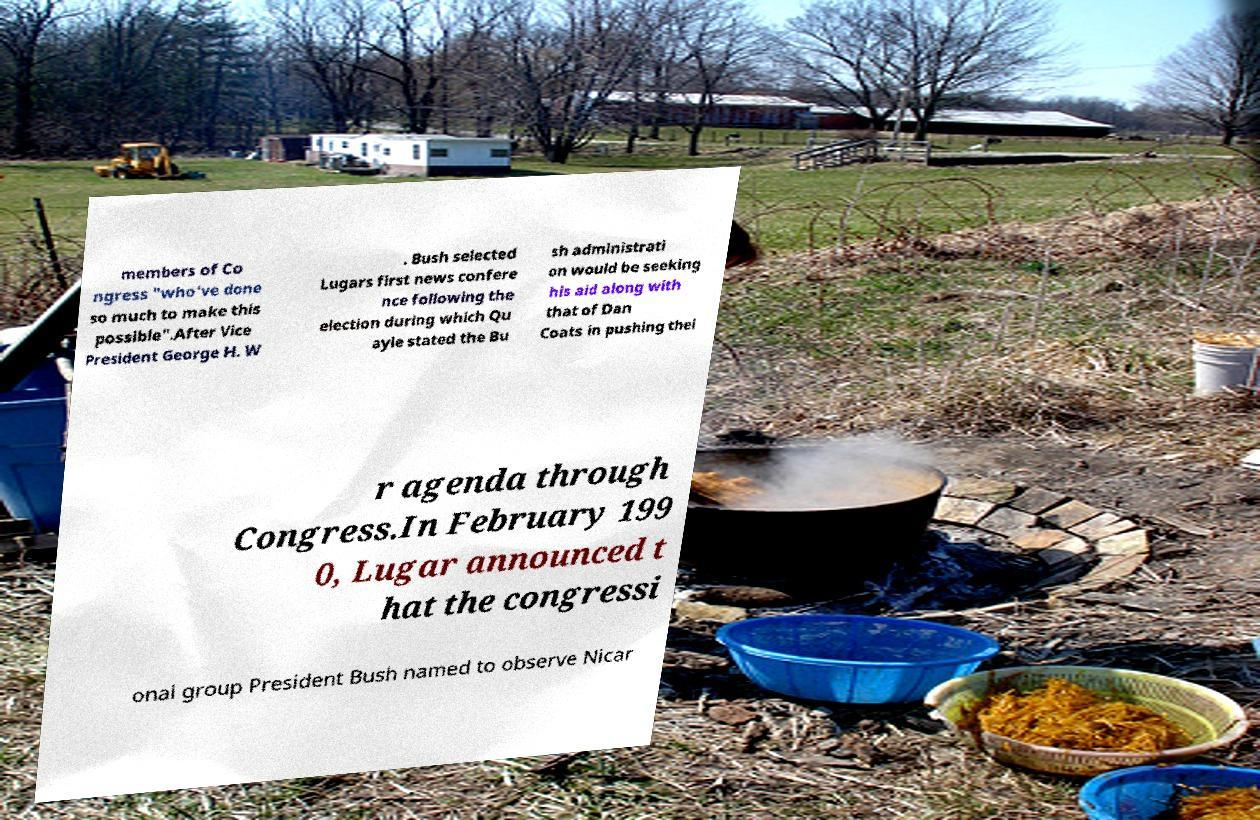For documentation purposes, I need the text within this image transcribed. Could you provide that? members of Co ngress "who've done so much to make this possible".After Vice President George H. W . Bush selected Lugars first news confere nce following the election during which Qu ayle stated the Bu sh administrati on would be seeking his aid along with that of Dan Coats in pushing thei r agenda through Congress.In February 199 0, Lugar announced t hat the congressi onal group President Bush named to observe Nicar 